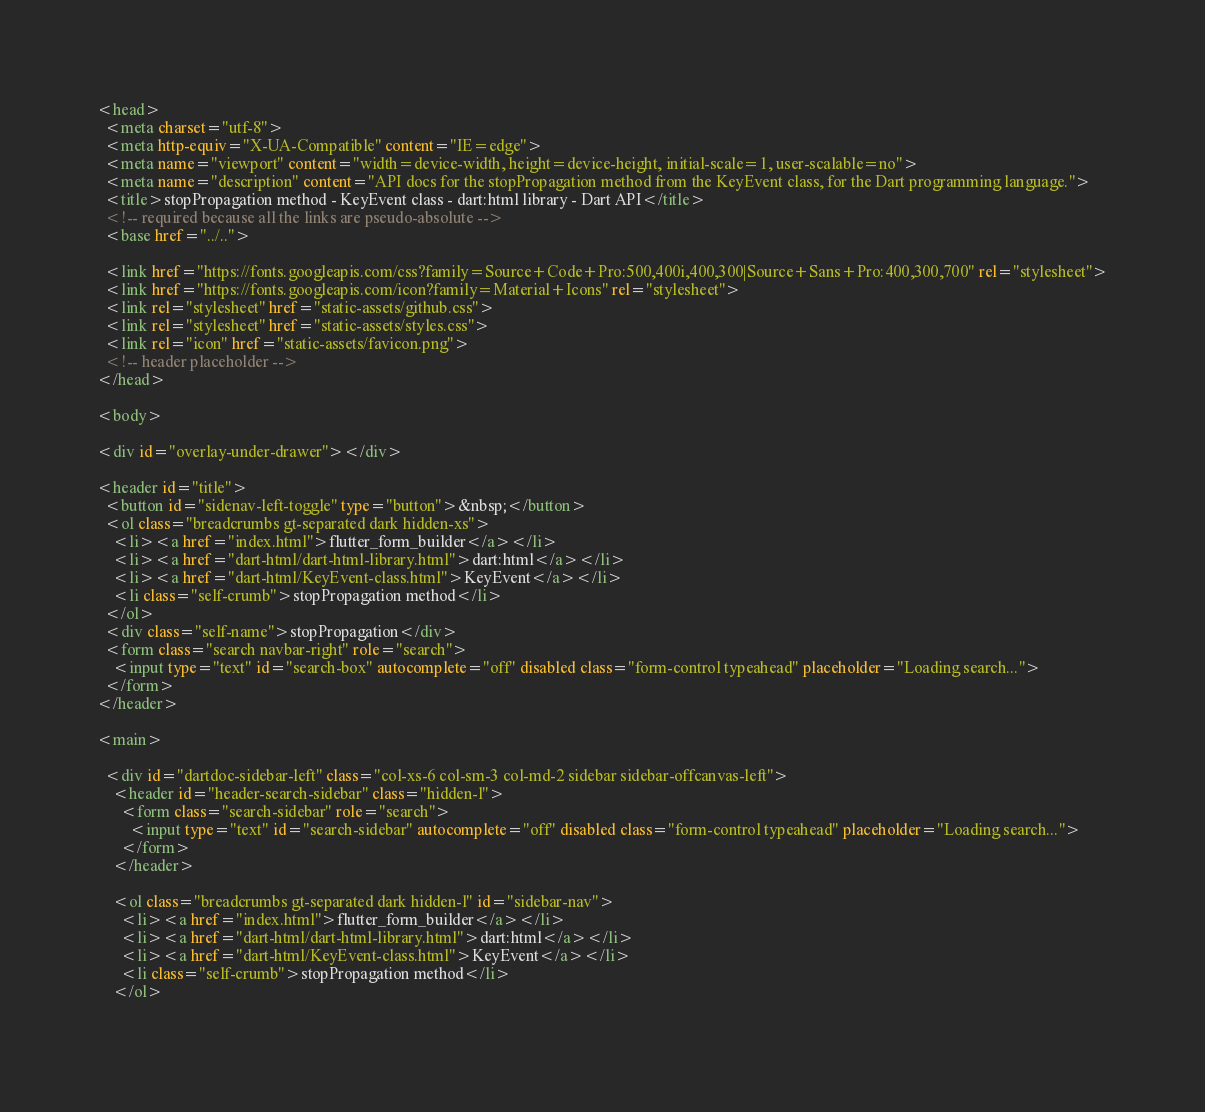Convert code to text. <code><loc_0><loc_0><loc_500><loc_500><_HTML_><head>
  <meta charset="utf-8">
  <meta http-equiv="X-UA-Compatible" content="IE=edge">
  <meta name="viewport" content="width=device-width, height=device-height, initial-scale=1, user-scalable=no">
  <meta name="description" content="API docs for the stopPropagation method from the KeyEvent class, for the Dart programming language.">
  <title>stopPropagation method - KeyEvent class - dart:html library - Dart API</title>
  <!-- required because all the links are pseudo-absolute -->
  <base href="../..">

  <link href="https://fonts.googleapis.com/css?family=Source+Code+Pro:500,400i,400,300|Source+Sans+Pro:400,300,700" rel="stylesheet">
  <link href="https://fonts.googleapis.com/icon?family=Material+Icons" rel="stylesheet">
  <link rel="stylesheet" href="static-assets/github.css">
  <link rel="stylesheet" href="static-assets/styles.css">
  <link rel="icon" href="static-assets/favicon.png">
  <!-- header placeholder -->
</head>

<body>

<div id="overlay-under-drawer"></div>

<header id="title">
  <button id="sidenav-left-toggle" type="button">&nbsp;</button>
  <ol class="breadcrumbs gt-separated dark hidden-xs">
    <li><a href="index.html">flutter_form_builder</a></li>
    <li><a href="dart-html/dart-html-library.html">dart:html</a></li>
    <li><a href="dart-html/KeyEvent-class.html">KeyEvent</a></li>
    <li class="self-crumb">stopPropagation method</li>
  </ol>
  <div class="self-name">stopPropagation</div>
  <form class="search navbar-right" role="search">
    <input type="text" id="search-box" autocomplete="off" disabled class="form-control typeahead" placeholder="Loading search...">
  </form>
</header>

<main>

  <div id="dartdoc-sidebar-left" class="col-xs-6 col-sm-3 col-md-2 sidebar sidebar-offcanvas-left">
    <header id="header-search-sidebar" class="hidden-l">
      <form class="search-sidebar" role="search">
        <input type="text" id="search-sidebar" autocomplete="off" disabled class="form-control typeahead" placeholder="Loading search...">
      </form>
    </header>
    
    <ol class="breadcrumbs gt-separated dark hidden-l" id="sidebar-nav">
      <li><a href="index.html">flutter_form_builder</a></li>
      <li><a href="dart-html/dart-html-library.html">dart:html</a></li>
      <li><a href="dart-html/KeyEvent-class.html">KeyEvent</a></li>
      <li class="self-crumb">stopPropagation method</li>
    </ol>
    </code> 